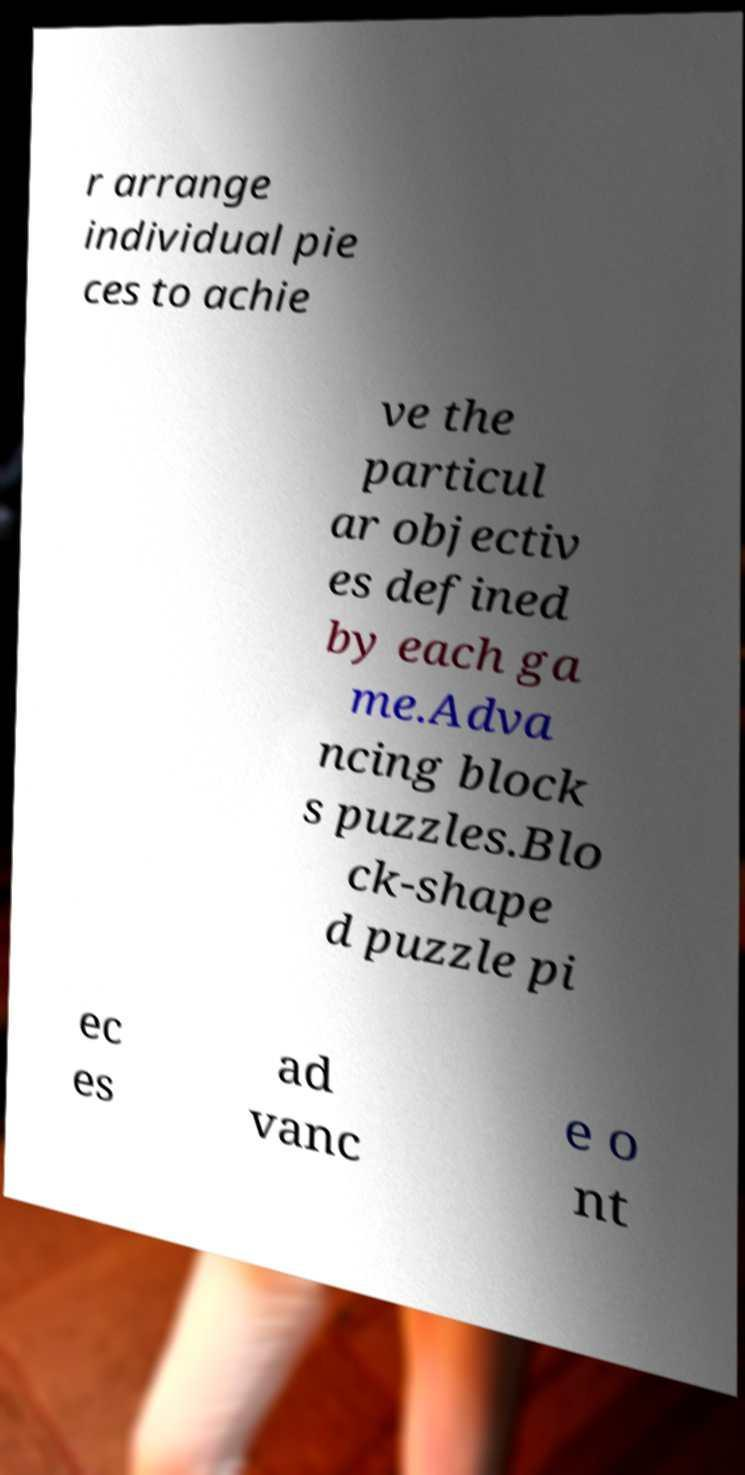Can you read and provide the text displayed in the image?This photo seems to have some interesting text. Can you extract and type it out for me? r arrange individual pie ces to achie ve the particul ar objectiv es defined by each ga me.Adva ncing block s puzzles.Blo ck-shape d puzzle pi ec es ad vanc e o nt 